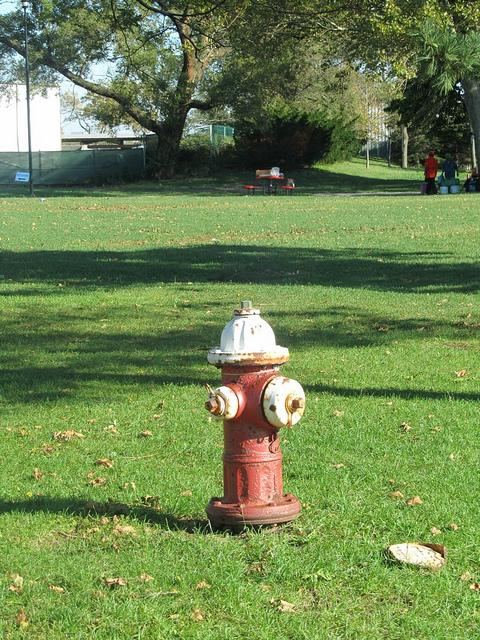Where is the fire hydrant located?

Choices:
A) park
B) village
C) city
D) farm park 